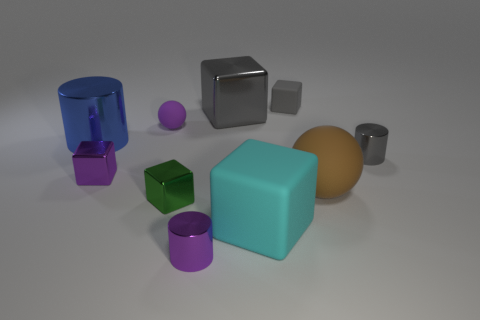Subtract all gray blocks. How many blocks are left? 3 Subtract all purple blocks. How many blocks are left? 4 Subtract all spheres. How many objects are left? 8 Subtract 5 cubes. How many cubes are left? 0 Subtract 0 red blocks. How many objects are left? 10 Subtract all yellow blocks. Subtract all blue balls. How many blocks are left? 5 Subtract all purple spheres. How many red cylinders are left? 0 Subtract all gray metallic blocks. Subtract all large cyan matte blocks. How many objects are left? 8 Add 9 tiny green metallic blocks. How many tiny green metallic blocks are left? 10 Add 6 yellow metal balls. How many yellow metal balls exist? 6 